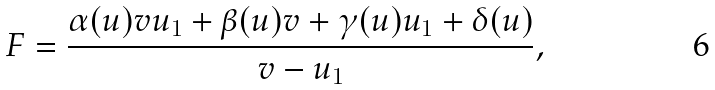Convert formula to latex. <formula><loc_0><loc_0><loc_500><loc_500>F = \frac { \alpha ( u ) v u _ { 1 } + \beta ( u ) v + \gamma ( u ) u _ { 1 } + \delta ( u ) } { v - u _ { 1 } } ,</formula> 